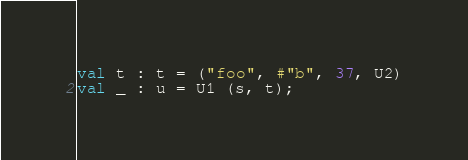Convert code to text. <code><loc_0><loc_0><loc_500><loc_500><_SML_>val t : t = ("foo", #"b", 37, U2)
val _ : u = U1 (s, t);
</code> 